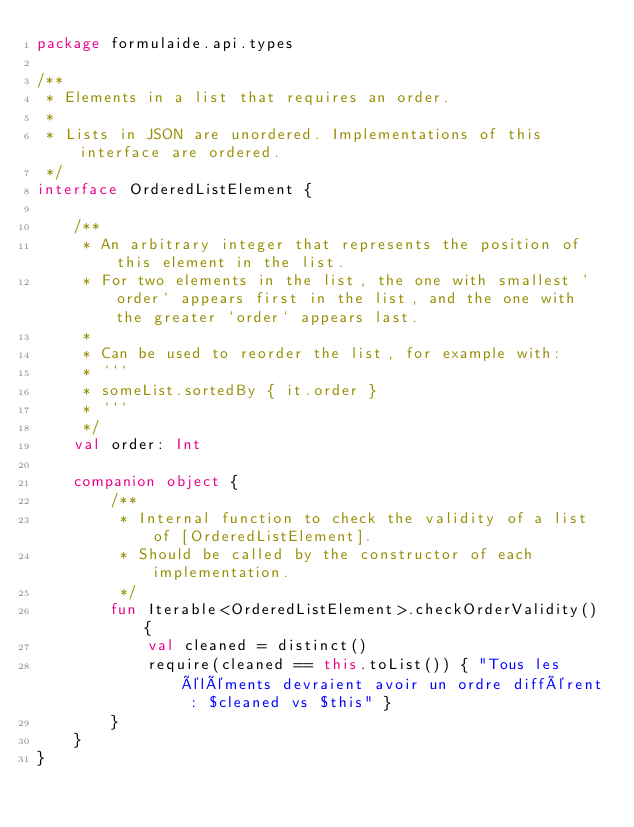Convert code to text. <code><loc_0><loc_0><loc_500><loc_500><_Kotlin_>package formulaide.api.types

/**
 * Elements in a list that requires an order.
 *
 * Lists in JSON are unordered. Implementations of this interface are ordered.
 */
interface OrderedListElement {

	/**
	 * An arbitrary integer that represents the position of this element in the list.
	 * For two elements in the list, the one with smallest `order` appears first in the list, and the one with the greater `order` appears last.
	 *
	 * Can be used to reorder the list, for example with:
	 * ```
	 * someList.sortedBy { it.order }
	 * ```
	 */
	val order: Int

	companion object {
		/**
		 * Internal function to check the validity of a list of [OrderedListElement].
		 * Should be called by the constructor of each implementation.
		 */
		fun Iterable<OrderedListElement>.checkOrderValidity() {
			val cleaned = distinct()
			require(cleaned == this.toList()) { "Tous les éléments devraient avoir un ordre différent : $cleaned vs $this" }
		}
	}
}
</code> 